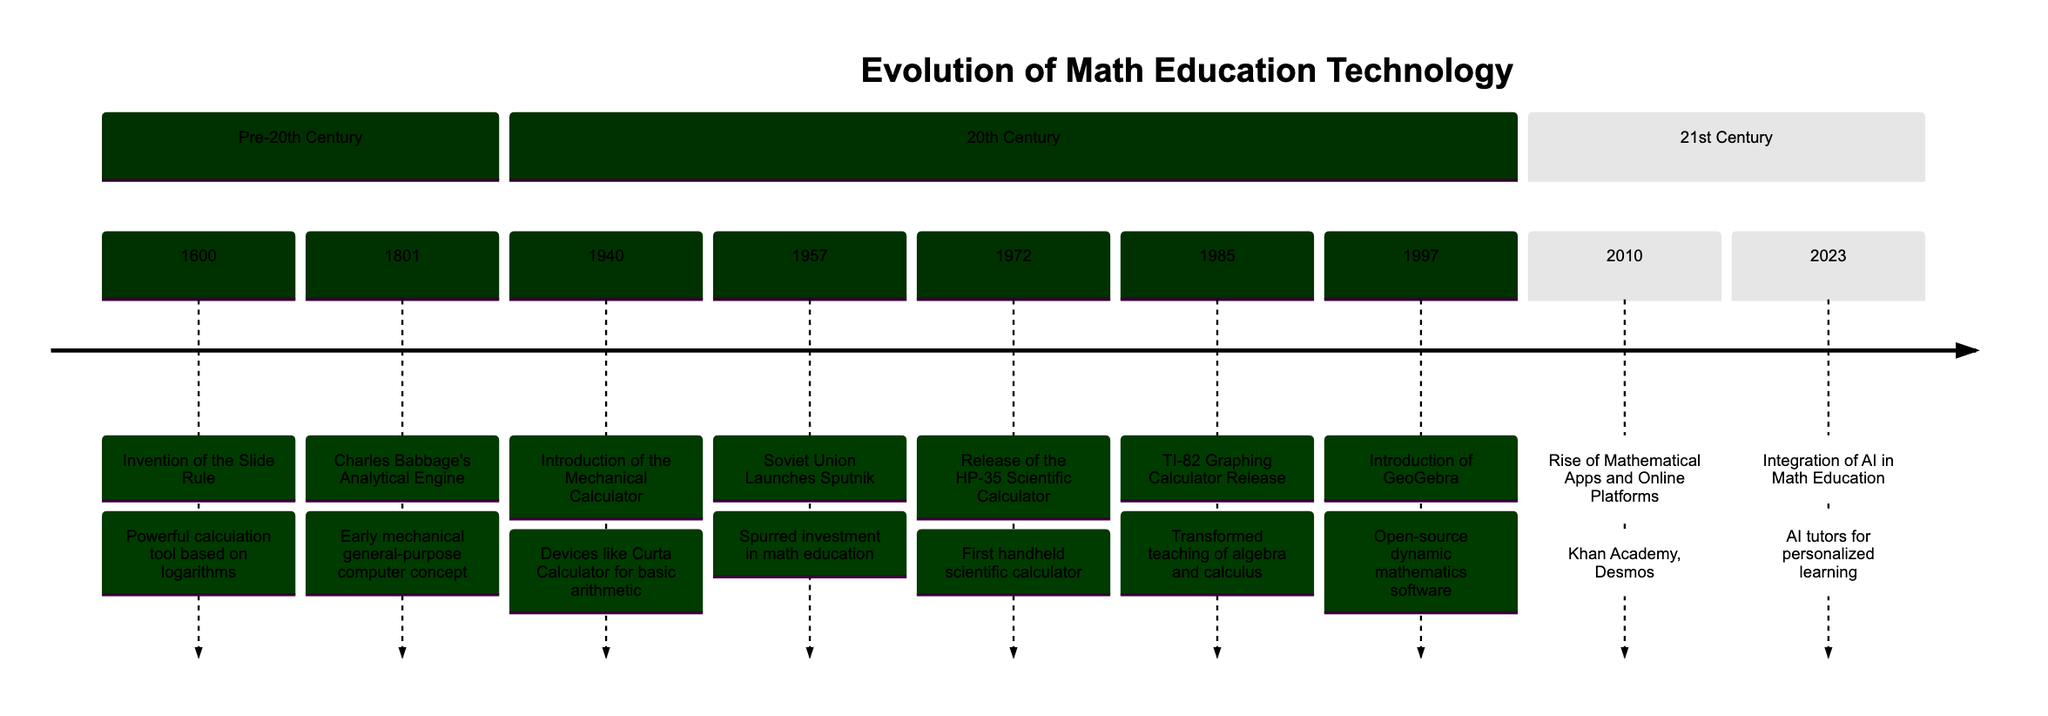What was invented in 1600? The diagram indicates that the slide rule was invented in 1600, detailing its significance as a powerful calculation tool based on logarithms.
Answer: Slide Rule Who conceptualized the Analytical Engine? The timeline states that the Analytical Engine was conceptualized by Charles Babbage in 1801, and this information can be directly referenced from the diagram.
Answer: Charles Babbage What event in 1957 spurred investment in math education? According to the diagram, the launch of Sputnik by the Soviet Union in 1957 motivated the U.S. to invest in math and science education.
Answer: Sputnik Which technology transformed the teaching of algebra and calculus in 1985? The TI-82 Graphing Calculator, released in 1985 as indicated in the timeline, notably transformed the teaching methods for algebra and calculus.
Answer: TI-82 Graphing Calculator How many major events are listed in the 21st Century section? By counting each event in the 21st Century section of the timeline, we can see that there are two key events listed.
Answer: 2 What educational tools became prevalent in 2010? The diagram highlights the rise of mathematical apps and online platforms, specifically naming Khan Academy and Desmos as primary examples.
Answer: Khan Academy and Desmos Which year saw the release of GeoGebra? The timeline specifies that GeoGebra was introduced in 1997, directly answering the question about its release year.
Answer: 1997 What was the first handheld scientific calculator released? The timeline notes that the HP-35 was released in 1972 and was recognized as the first handheld scientific calculator.
Answer: HP-35 What is a significant feature of AI integration in math education in 2023? The diagram states that AI tutors are becoming prevalent, indicating a direction towards personalized learning experiences in math education.
Answer: AI Tutors 